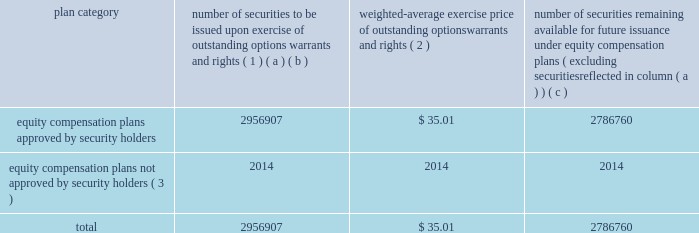Equity compensation plan information the table presents the equity securities available for issuance under our equity compensation plans as of december 31 , 2013 .
Equity compensation plan information plan category number of securities to be issued upon exercise of outstanding options , warrants and rights ( 1 ) weighted-average exercise price of outstanding options , warrants and rights ( 2 ) number of securities remaining available for future issuance under equity compensation plans ( excluding securities reflected in column ( a ) ) ( a ) ( b ) ( c ) equity compensation plans approved by security holders 2956907 $ 35.01 2786760 equity compensation plans not approved by security holders ( 3 ) 2014 2014 2014 .
( 1 ) includes grants made under the huntington ingalls industries , inc .
2012 long-term incentive stock plan ( the "2012 plan" ) , which was approved by our stockholders on may 2 , 2012 , and the huntington ingalls industries , inc .
2011 long-term incentive stock plan ( the "2011 plan" ) , which was approved by the sole stockholder of hii prior to its spin-off from northrop grumman corporation .
Of these shares , 818723 were subject to stock options , 1002217 were subject to outstanding restricted performance stock rights , 602400 were restricted stock rights , and 63022 were stock rights granted under the 2011 plan .
In addition , this number includes 24428 stock rights and 446117 restricted performance stock rights granted under the 2012 plan , assuming target performance achievement .
( 2 ) this is the weighted average exercise price of the 818723 outstanding stock options only .
( 3 ) there are no awards made under plans not approved by security holders .
Item 13 .
Certain relationships and related transactions , and director independence information as to certain relationships and related transactions and director independence will be incorporated herein by reference to the proxy statement for our 2014 annual meeting of stockholders to be filed within 120 days after the end of the company 2019s fiscal year .
Item 14 .
Principal accountant fees and services information as to principal accountant fees and services will be incorporated herein by reference to the proxy statement for our 2014 annual meeting of stockholders to be filed within 120 days after the end of the company 2019s fiscal year. .
As of december 31 , 2013 , what is the value of securities remaining available for future issuance? 
Rationale: the value is the product of the number of securities and the price
Computations: (2786760 * 35.01)
Answer: 97564467.6. 